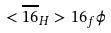Convert formula to latex. <formula><loc_0><loc_0><loc_500><loc_500>< \overline { 1 6 } _ { H } > 1 6 _ { f } \phi</formula> 